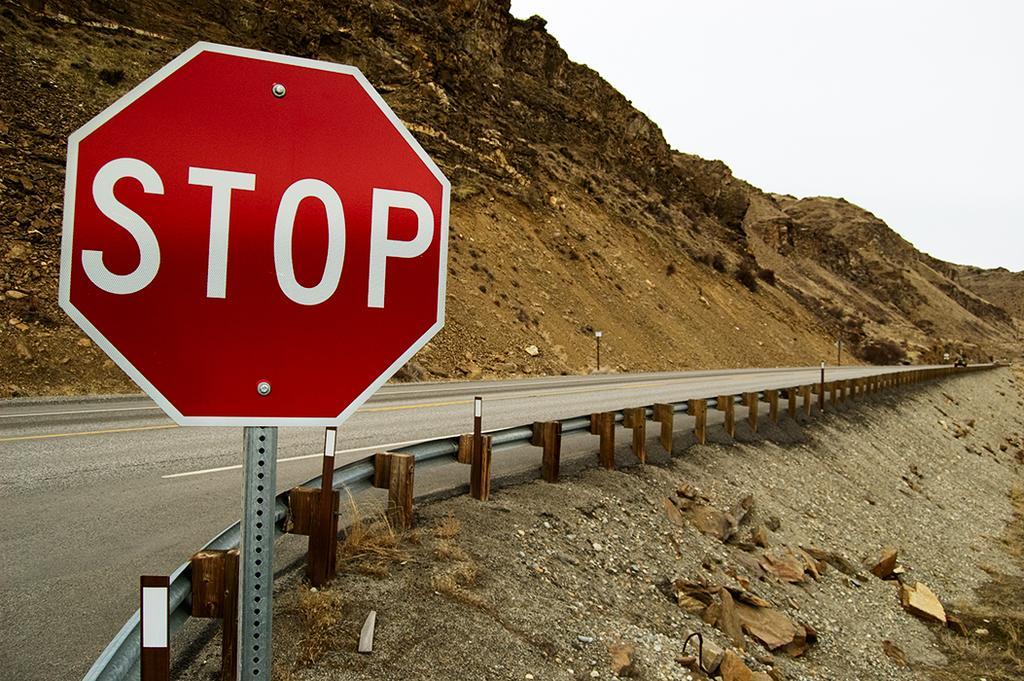Could you give a brief overview of what you see in this image? In this image there is a caution board in the middle. Behind the caution board there is a road. Beside the road there is fence. At the bottom there is sand on which there are stones. In the background there is a hill with the sand. 